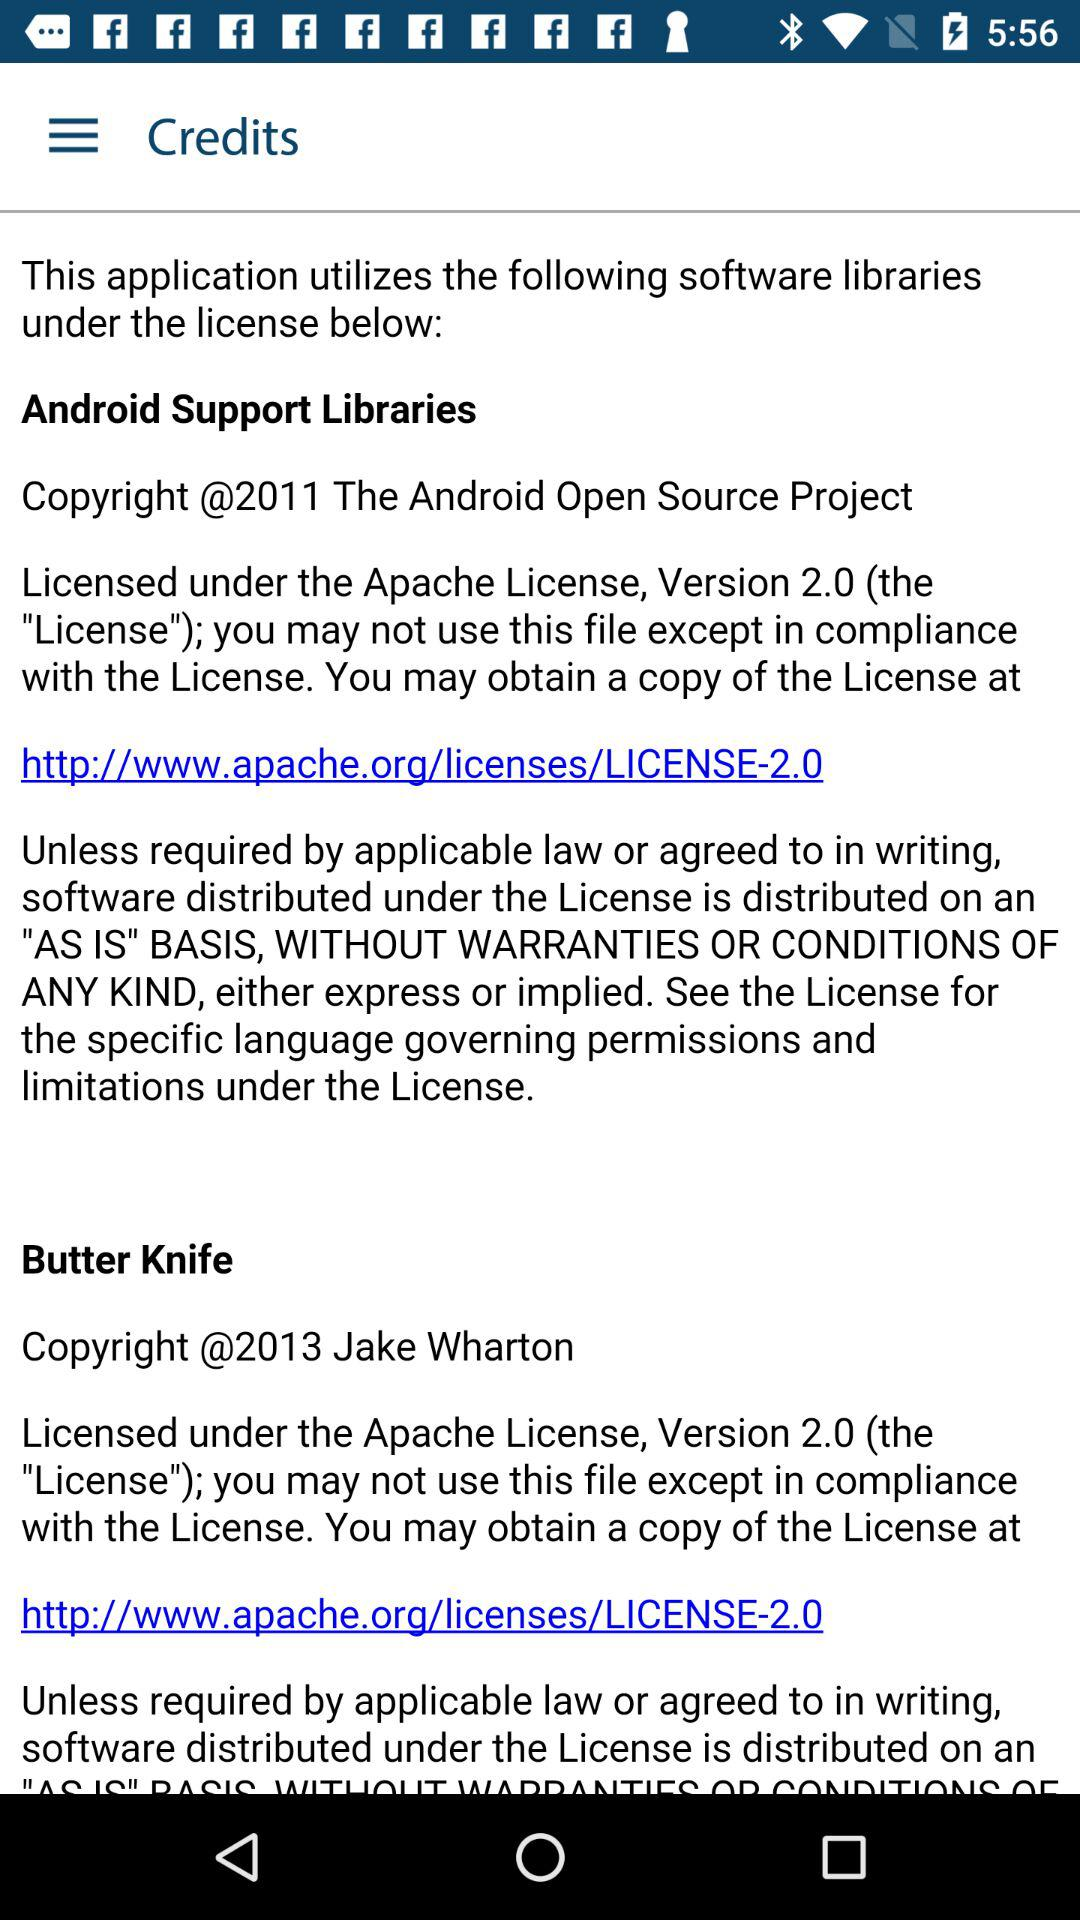How many software libraries are licensed under the Apache License 2.0?
Answer the question using a single word or phrase. 2 